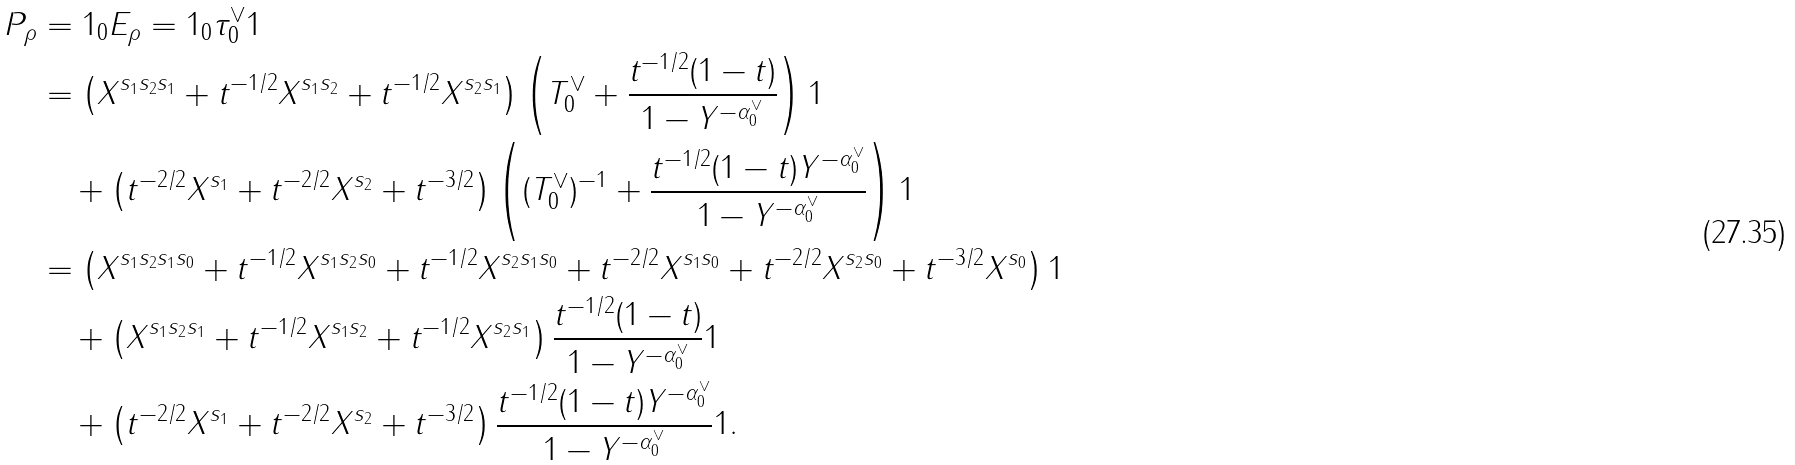Convert formula to latex. <formula><loc_0><loc_0><loc_500><loc_500>P _ { \rho } & = 1 _ { 0 } E _ { \rho } = 1 _ { 0 } \tau _ { 0 } ^ { \vee } 1 \\ & = \left ( X ^ { s _ { 1 } s _ { 2 } s _ { 1 } } + t ^ { - 1 / 2 } X ^ { s _ { 1 } s _ { 2 } } + t ^ { - 1 / 2 } X ^ { s _ { 2 } s _ { 1 } } \right ) \left ( T _ { 0 } ^ { \vee } + \frac { t ^ { - 1 / 2 } ( 1 - t ) } { 1 - Y ^ { - \alpha _ { 0 } ^ { \vee } } } \right ) 1 \\ & \quad + \left ( t ^ { - 2 / 2 } X ^ { s _ { 1 } } + t ^ { - 2 / 2 } X ^ { s _ { 2 } } + t ^ { - 3 / 2 } \right ) \left ( ( T _ { 0 } ^ { \vee } ) ^ { - 1 } + \frac { t ^ { - 1 / 2 } ( 1 - t ) Y ^ { - \alpha _ { 0 } ^ { \vee } } } { 1 - Y ^ { - \alpha _ { 0 } ^ { \vee } } } \right ) 1 \\ & = \left ( X ^ { s _ { 1 } s _ { 2 } s _ { 1 } s _ { 0 } } + t ^ { - 1 / 2 } X ^ { s _ { 1 } s _ { 2 } s _ { 0 } } + t ^ { - 1 / 2 } X ^ { s _ { 2 } s _ { 1 } s _ { 0 } } + t ^ { - 2 / 2 } X ^ { s _ { 1 } s _ { 0 } } + t ^ { - 2 / 2 } X ^ { s _ { 2 } s _ { 0 } } + t ^ { - 3 / 2 } X ^ { s _ { 0 } } \right ) 1 \\ & \quad + \left ( X ^ { s _ { 1 } s _ { 2 } s _ { 1 } } + t ^ { - 1 / 2 } X ^ { s _ { 1 } s _ { 2 } } + t ^ { - 1 / 2 } X ^ { s _ { 2 } s _ { 1 } } \right ) \frac { t ^ { - 1 / 2 } ( 1 - t ) } { 1 - Y ^ { - \alpha _ { 0 } ^ { \vee } } } 1 \\ & \quad + \left ( t ^ { - 2 / 2 } X ^ { s _ { 1 } } + t ^ { - 2 / 2 } X ^ { s _ { 2 } } + t ^ { - 3 / 2 } \right ) \frac { t ^ { - 1 / 2 } ( 1 - t ) Y ^ { - \alpha _ { 0 } ^ { \vee } } } { 1 - Y ^ { - \alpha _ { 0 } ^ { \vee } } } 1 .</formula> 